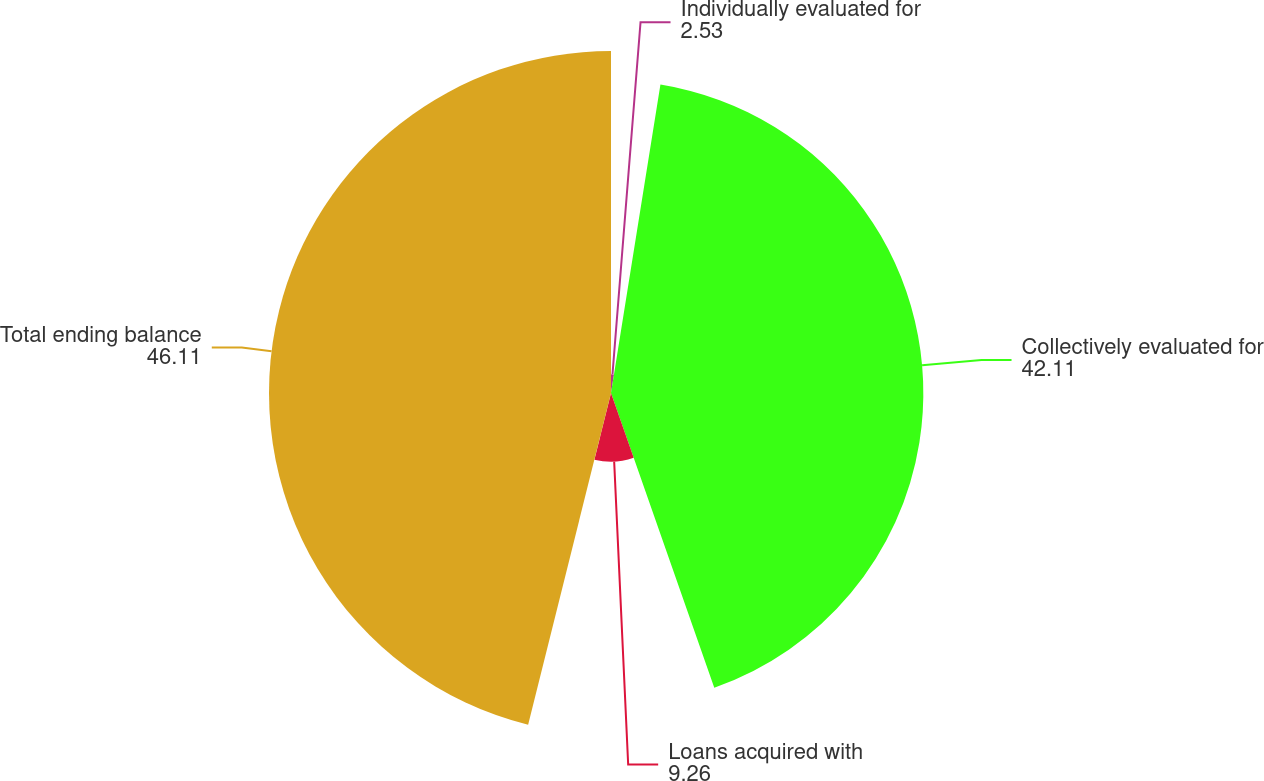<chart> <loc_0><loc_0><loc_500><loc_500><pie_chart><fcel>Individually evaluated for<fcel>Collectively evaluated for<fcel>Loans acquired with<fcel>Total ending balance<nl><fcel>2.53%<fcel>42.11%<fcel>9.26%<fcel>46.11%<nl></chart> 